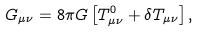<formula> <loc_0><loc_0><loc_500><loc_500>G _ { \mu \nu } = 8 \pi G \left [ T ^ { 0 } _ { \mu \nu } + \delta T _ { \mu \nu } \right ] ,</formula> 